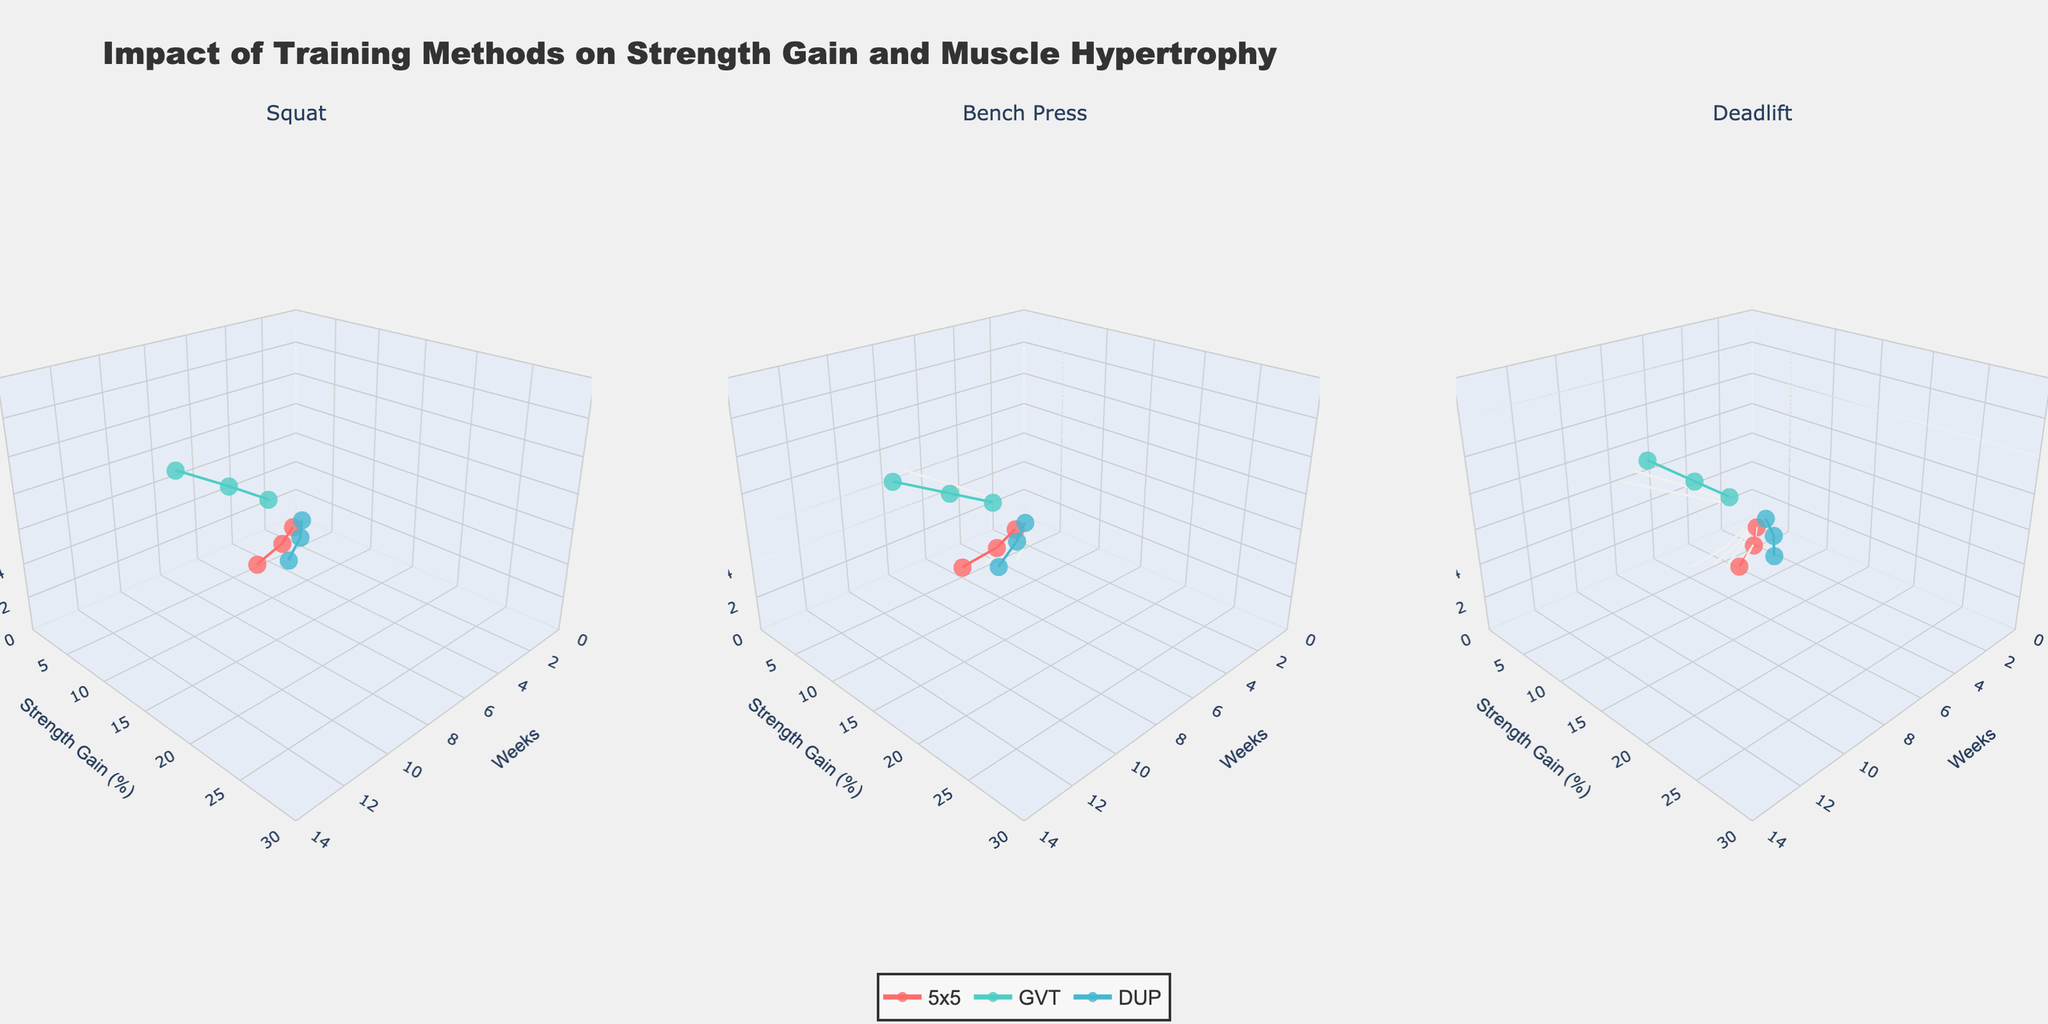How many compound exercises are displayed in the figure? The figure contains subplots for each exercise. By looking at the titles of the subplots, we can count the number of exercises shown.
Answer: 3 Which training method shows the highest increase in strength gain percentage for the Deadlift over 12 weeks? In the subplot for Deadlift, compare the height of the lines representing strength gain for each training method at the 12-week mark.
Answer: DUP What is the difference in muscle hypertrophy percentage after 8 weeks between the 5x5 and GVT methods for the Bench Press? Check the z-axis values for muscle hypertrophy at the 8-week mark for both the 5x5 and GVT methods in the Bench Press subplot. Subtract the GVT value from the 5x5 value.
Answer: -1.9 Which exercise shows the highest overall strength gain across all training methods after 12 weeks? Compare the y-axis values for strength gain at the 12-week mark across all subplots (Squat, Bench Press, Deadlift). Identify the highest value.
Answer: Deadlift How does muscle hypertrophy for the GVT method after 12 weeks compare across Squat and Deadlift? Locate the z-axis values for muscle hypertrophy at the 12-week mark for the GVT method in both the Squat and Deadlift subplots. Compare the two values.
Answer: Higher in Deadlift After 4 weeks, which training method leads to the highest strength gain in the Squat exercise? Look at the strength gain percentage on the y-axis at the 4-week mark for each method in the Squat subplot. Determine which method has the highest value.
Answer: DUP What is the approximate range of muscle hypertrophy percentages shown for all exercises and training methods combined? Identify the minimum and maximum values on the z-axis across all subplots and training methods for muscle hypertrophy percentages. Subtract the minimum from the maximum value to find the range.
Answer: 0 to 14 Does the 5x5 training method show the same trend in strength gain over 12 weeks in all exercises? Observe the trend lines for the 5x5 method in each subplot. Determine if the trend in strength gain percentage follows a similar pattern across Squat, Bench Press, and Deadlift.
Answer: Yes What is the combined muscle hypertrophy percentage after 8 weeks for all exercises using the GVT method? Find the muscle hypertrophy percentage at the 8-week mark for the GVT method for each exercise. Add these percentages together.
Answer: 23.3 